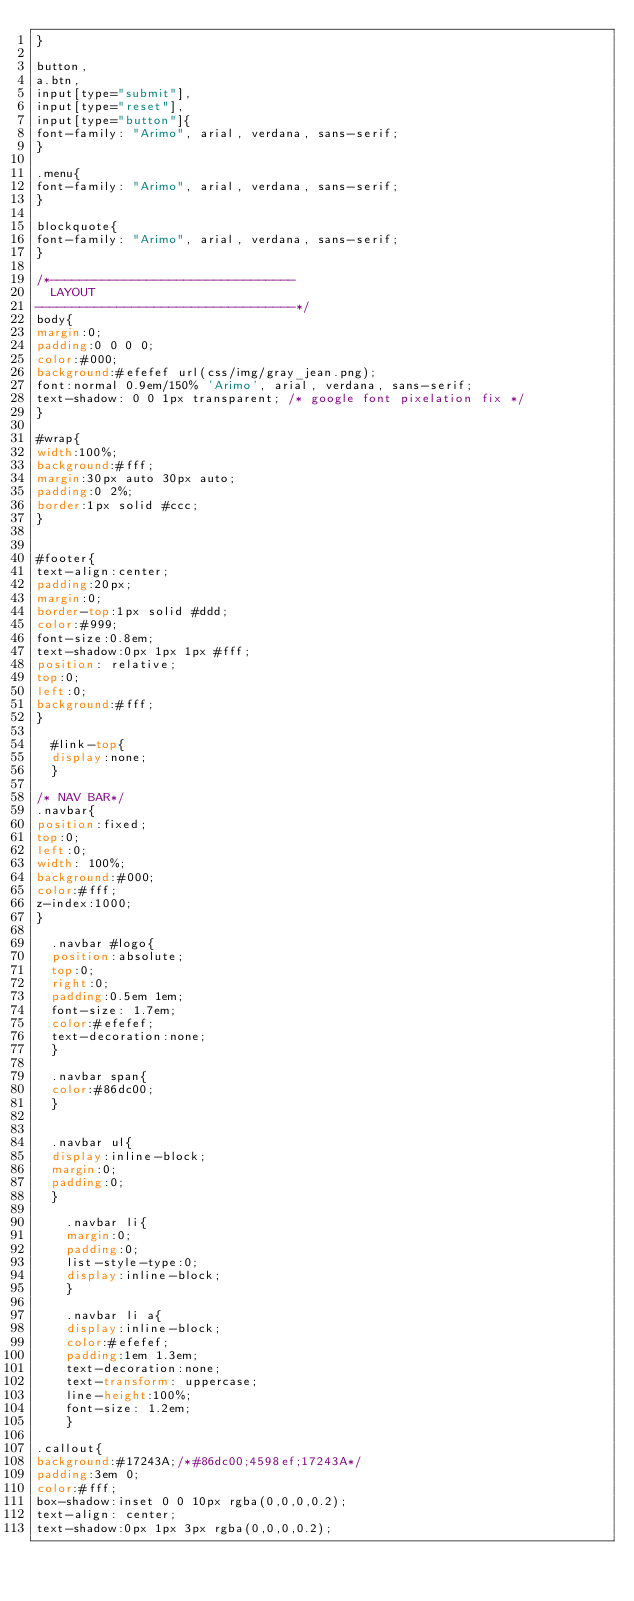<code> <loc_0><loc_0><loc_500><loc_500><_CSS_>}

button,
a.btn,
input[type="submit"],
input[type="reset"],
input[type="button"]{
font-family: "Arimo", arial, verdana, sans-serif;
}

.menu{
font-family: "Arimo", arial, verdana, sans-serif;
}

blockquote{
font-family: "Arimo", arial, verdana, sans-serif;
}

/*---------------------------------
	LAYOUT
-----------------------------------*/
body{
margin:0;
padding:0 0 0 0;
color:#000;
background:#efefef url(css/img/gray_jean.png);
font:normal 0.9em/150% 'Arimo', arial, verdana, sans-serif;
text-shadow: 0 0 1px transparent; /* google font pixelation fix */
}

#wrap{
width:100%;
background:#fff;
margin:30px auto 30px auto;
padding:0 2%;
border:1px solid #ccc;
}


#footer{
text-align:center;
padding:20px;
margin:0;
border-top:1px solid #ddd;
color:#999;
font-size:0.8em;
text-shadow:0px 1px 1px #fff;
position: relative;
top:0;
left:0;
background:#fff;
}

	#link-top{
	display:none;
	}

/* NAV BAR*/
.navbar{
position:fixed;
top:0;
left:0;
width: 100%;
background:#000;
color:#fff;
z-index:1000;
}

	.navbar #logo{
	position:absolute;
	top:0;
	right:0;
	padding:0.5em 1em;
	font-size: 1.7em;
	color:#efefef;
	text-decoration:none;
	}

	.navbar span{
	color:#86dc00;
	}


	.navbar ul{
	display:inline-block;
	margin:0;
	padding:0;
	}

		.navbar li{
		margin:0;
		padding:0;
		list-style-type:0;
		display:inline-block;
		}

		.navbar li a{
		display:inline-block;
		color:#efefef;
		padding:1em 1.3em;
		text-decoration:none;
		text-transform: uppercase;
		line-height:100%;
		font-size: 1.2em;
		}

.callout{
background:#17243A;/*#86dc00;4598ef;17243A*/ 
padding:3em 0;
color:#fff;
box-shadow:inset 0 0 10px rgba(0,0,0,0.2);
text-align: center;
text-shadow:0px 1px 3px rgba(0,0,0,0.2);</code> 